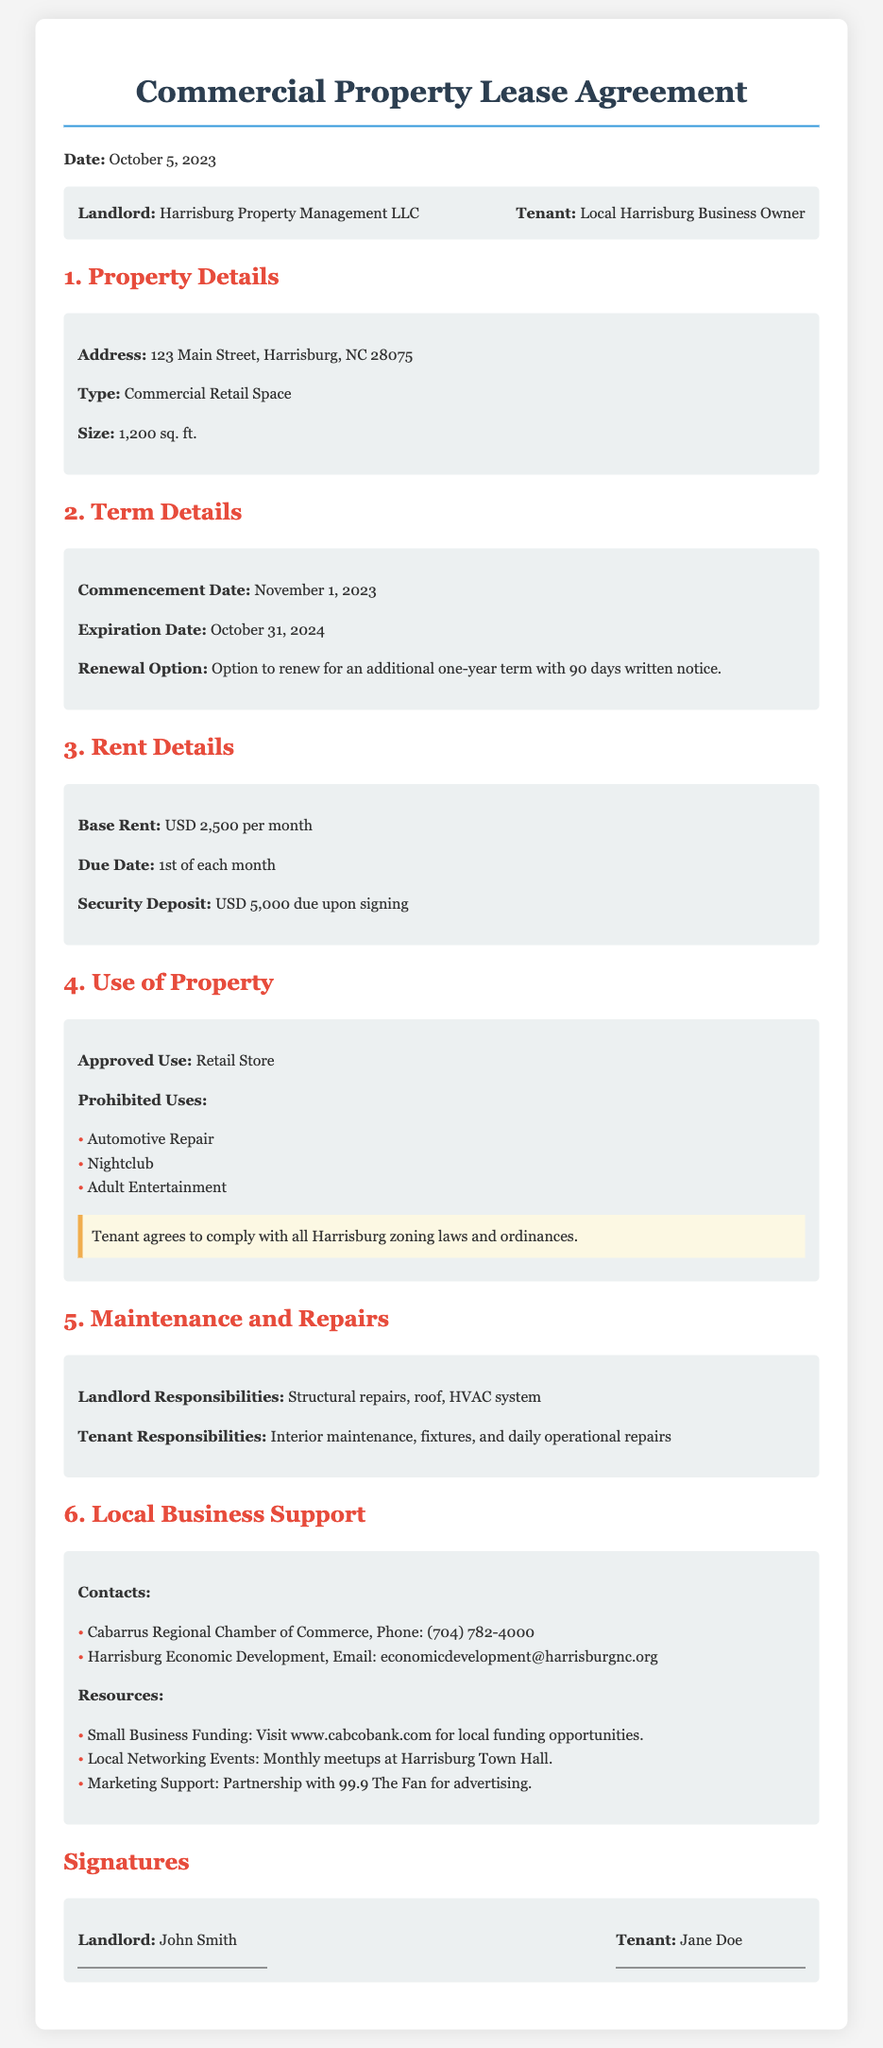What is the base rent? The base rent is specified in the Rent Details section of the document as USD 2,500 per month.
Answer: USD 2,500 per month What is the due date for rent payment? The due date for rent payment is mentioned in the Rent Details section of the document.
Answer: 1st of each month Who is the landlord? The landlord's name is stated in the parties section of the document as Harrisburg Property Management LLC.
Answer: Harrisburg Property Management LLC What is the expiration date of the lease? The expiration date is indicated in the Term Details section of the document.
Answer: October 31, 2024 What is one of the prohibited uses? The prohibited uses are listed in the Use of Property section of the document.
Answer: Automotive Repair What is the size of the property? The size of the property is detailed in the Property Details section of the document.
Answer: 1,200 sq. ft What option does the tenant have at the end of the lease term? The renewal option is specified in the Term Details section of the document.
Answer: Option to renew for an additional one-year term What support is provided for local businesses? Support for local businesses is outlined in the Local Business Support section of the document.
Answer: Contacts and Resources What is the security deposit amount? The amount of the security deposit is defined in the Rent Details section of the document.
Answer: USD 5,000 